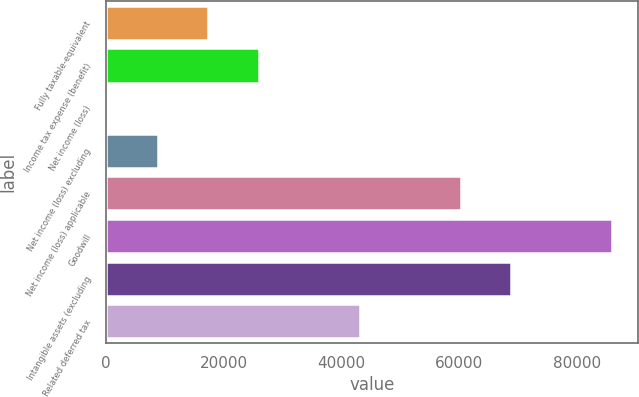Convert chart. <chart><loc_0><loc_0><loc_500><loc_500><bar_chart><fcel>Fully taxable-equivalent<fcel>Income tax expense (benefit)<fcel>Net income (loss)<fcel>Net income (loss) excluding<fcel>Net income (loss) applicable<fcel>Goodwill<fcel>Intangible assets (excluding<fcel>Related deferred tax<nl><fcel>17365.8<fcel>25951.7<fcel>194<fcel>8779.9<fcel>60295.3<fcel>86053<fcel>68881.2<fcel>43123.5<nl></chart> 